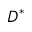<formula> <loc_0><loc_0><loc_500><loc_500>D ^ { * }</formula> 